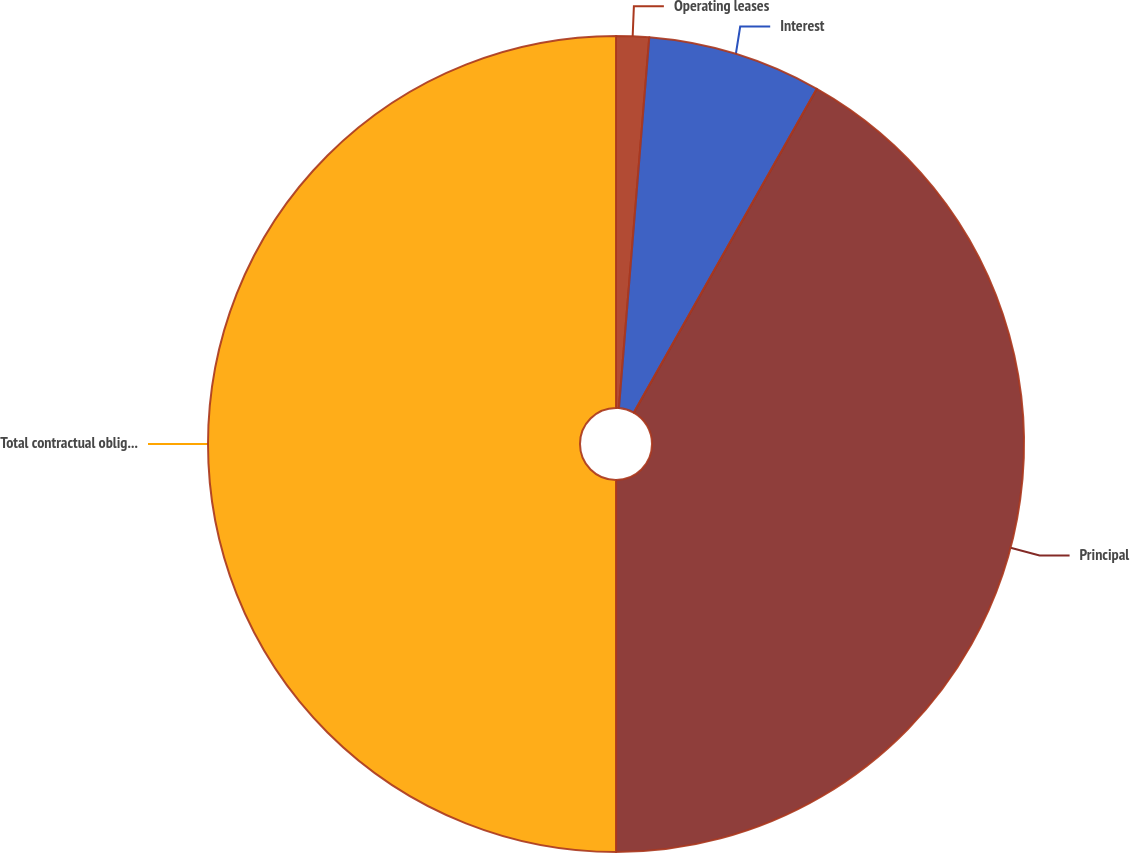Convert chart to OTSL. <chart><loc_0><loc_0><loc_500><loc_500><pie_chart><fcel>Operating leases<fcel>Interest<fcel>Principal<fcel>Total contractual obligations<nl><fcel>1.3%<fcel>6.89%<fcel>41.81%<fcel>50.0%<nl></chart> 